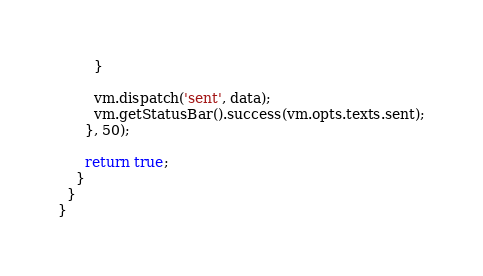<code> <loc_0><loc_0><loc_500><loc_500><_JavaScript_>        }

        vm.dispatch('sent', data);
        vm.getStatusBar().success(vm.opts.texts.sent);
      }, 50);

      return true;
    }
  }
}
</code> 